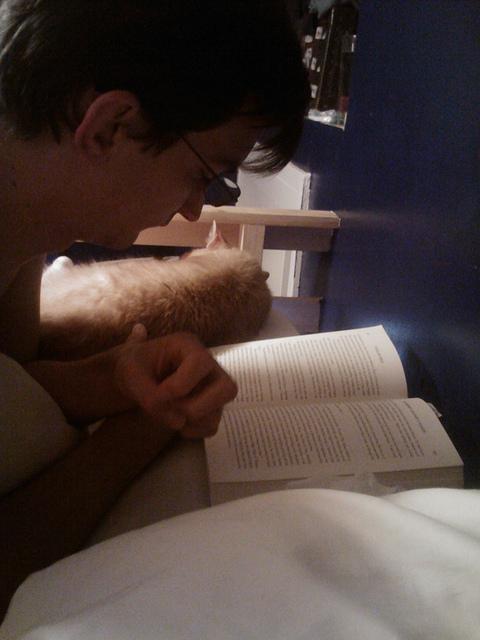What is the symbol the cat is sleeping in front of?
Write a very short answer. Cross. Does the man wear glasses?
Keep it brief. Yes. What is the man doing?
Quick response, please. Reading. How many books?
Quick response, please. 1. 